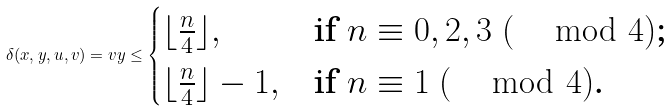Convert formula to latex. <formula><loc_0><loc_0><loc_500><loc_500>\delta ( x , y , u , v ) = v y \leq \begin{cases} \lfloor \frac { n } { 4 } \rfloor , & \text {if $n\equiv 0,2,3\ (\, \mod 4)$;} \\ \lfloor \frac { n } { 4 } \rfloor - 1 , & \text {if $n\equiv 1\ (\, \mod 4)$.} \end{cases}</formula> 